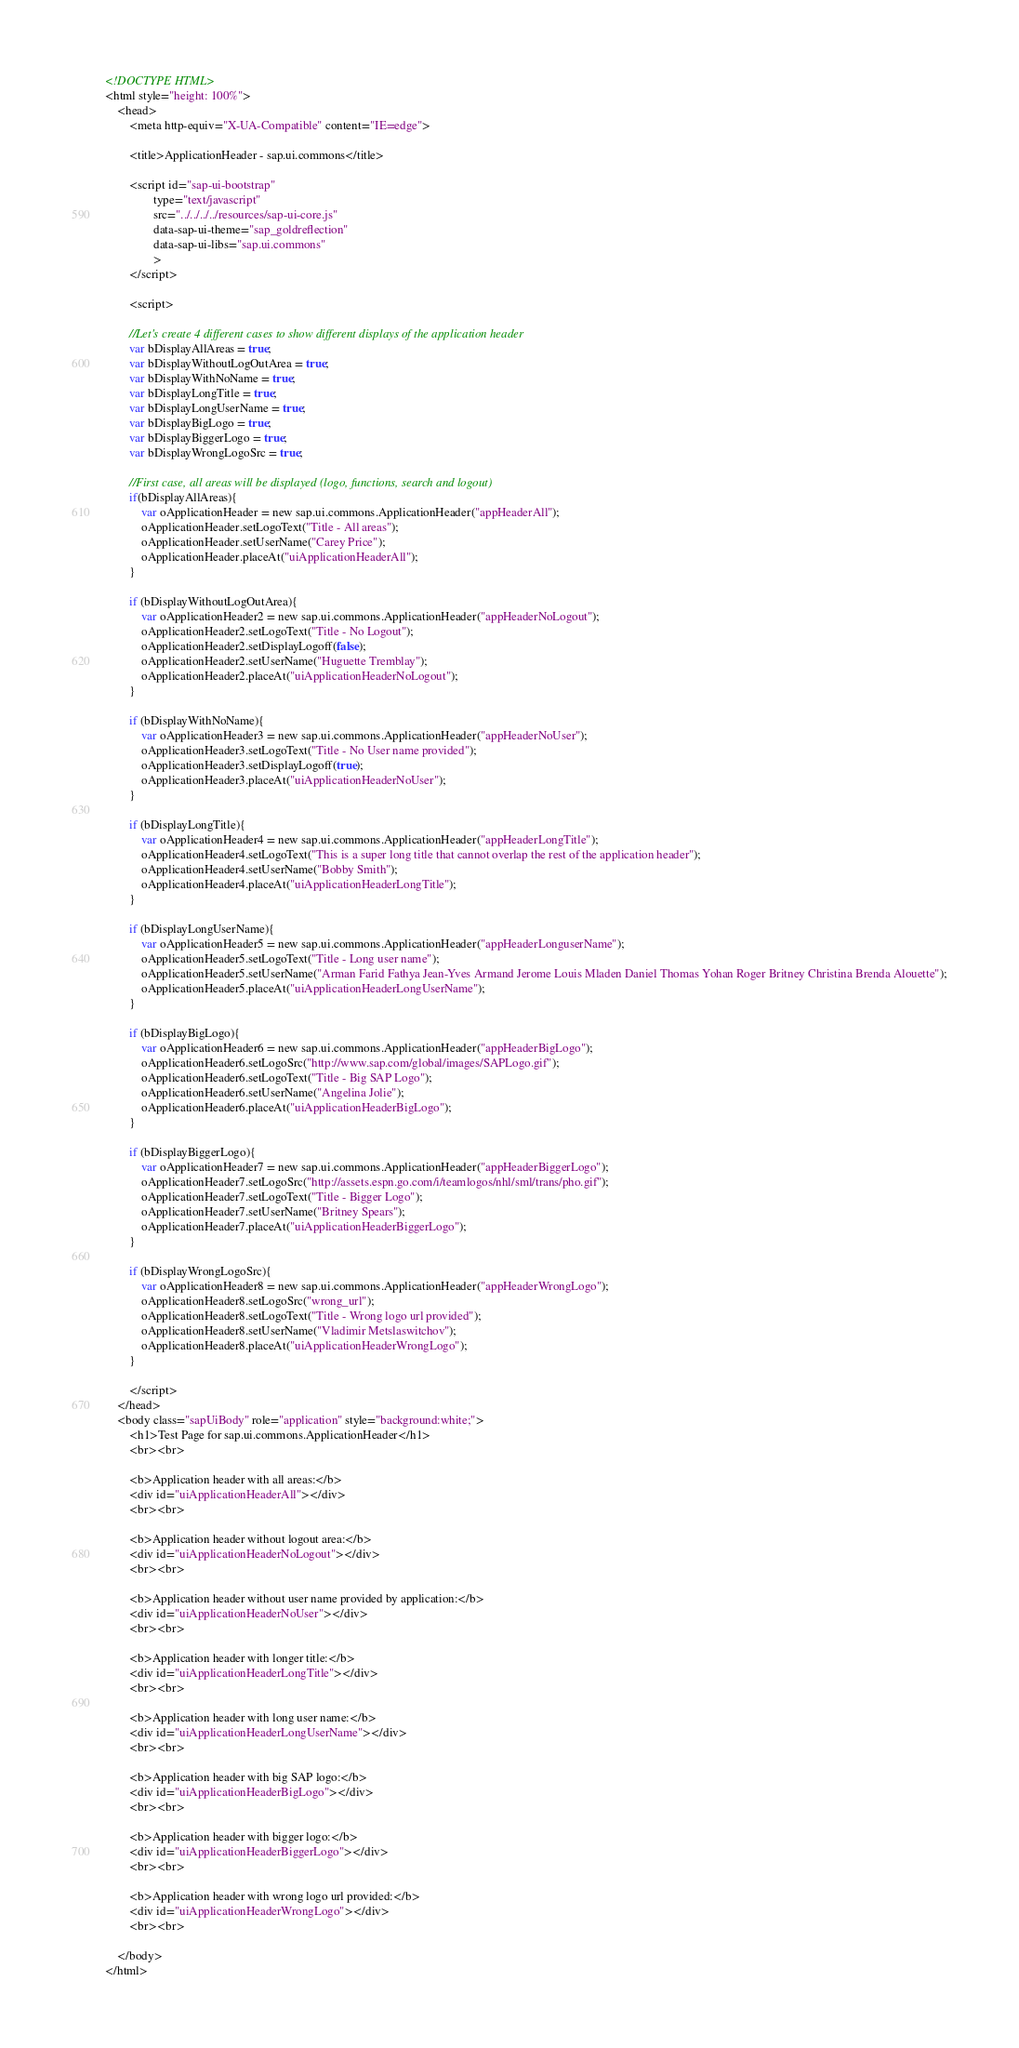<code> <loc_0><loc_0><loc_500><loc_500><_HTML_><!DOCTYPE HTML>
<html style="height: 100%">
	<head>
		<meta http-equiv="X-UA-Compatible" content="IE=edge">

		<title>ApplicationHeader - sap.ui.commons</title>

		<script id="sap-ui-bootstrap"
				type="text/javascript"
				src="../../../../resources/sap-ui-core.js"
				data-sap-ui-theme="sap_goldreflection"
				data-sap-ui-libs="sap.ui.commons"
				>
		</script>

		<script>

		//Let's create 4 different cases to show different displays of the application header
		var bDisplayAllAreas = true;
		var bDisplayWithoutLogOutArea = true;
		var bDisplayWithNoName = true;
		var bDisplayLongTitle = true;
		var bDisplayLongUserName = true;
		var bDisplayBigLogo = true;
		var bDisplayBiggerLogo = true;
		var bDisplayWrongLogoSrc = true;

		//First case, all areas will be displayed (logo, functions, search and logout)
		if(bDisplayAllAreas){
			var oApplicationHeader = new sap.ui.commons.ApplicationHeader("appHeaderAll");
			oApplicationHeader.setLogoText("Title - All areas");
			oApplicationHeader.setUserName("Carey Price");
			oApplicationHeader.placeAt("uiApplicationHeaderAll");
		}

		if (bDisplayWithoutLogOutArea){
			var oApplicationHeader2 = new sap.ui.commons.ApplicationHeader("appHeaderNoLogout");
			oApplicationHeader2.setLogoText("Title - No Logout");
			oApplicationHeader2.setDisplayLogoff(false);
			oApplicationHeader2.setUserName("Huguette Tremblay");
			oApplicationHeader2.placeAt("uiApplicationHeaderNoLogout");
		}

		if (bDisplayWithNoName){
			var oApplicationHeader3 = new sap.ui.commons.ApplicationHeader("appHeaderNoUser");
			oApplicationHeader3.setLogoText("Title - No User name provided");
			oApplicationHeader3.setDisplayLogoff(true);
			oApplicationHeader3.placeAt("uiApplicationHeaderNoUser");
		}

		if (bDisplayLongTitle){
			var oApplicationHeader4 = new sap.ui.commons.ApplicationHeader("appHeaderLongTitle");
			oApplicationHeader4.setLogoText("This is a super long title that cannot overlap the rest of the application header");
			oApplicationHeader4.setUserName("Bobby Smith");
			oApplicationHeader4.placeAt("uiApplicationHeaderLongTitle");
		}

		if (bDisplayLongUserName){
			var oApplicationHeader5 = new sap.ui.commons.ApplicationHeader("appHeaderLonguserName");
			oApplicationHeader5.setLogoText("Title - Long user name");
			oApplicationHeader5.setUserName("Arman Farid Fathya Jean-Yves Armand Jerome Louis Mladen Daniel Thomas Yohan Roger Britney Christina Brenda Alouette");
			oApplicationHeader5.placeAt("uiApplicationHeaderLongUserName");
		}

		if (bDisplayBigLogo){
			var oApplicationHeader6 = new sap.ui.commons.ApplicationHeader("appHeaderBigLogo");
			oApplicationHeader6.setLogoSrc("http://www.sap.com/global/images/SAPLogo.gif");
			oApplicationHeader6.setLogoText("Title - Big SAP Logo");
			oApplicationHeader6.setUserName("Angelina Jolie");
			oApplicationHeader6.placeAt("uiApplicationHeaderBigLogo");
		}

		if (bDisplayBiggerLogo){
			var oApplicationHeader7 = new sap.ui.commons.ApplicationHeader("appHeaderBiggerLogo");
			oApplicationHeader7.setLogoSrc("http://assets.espn.go.com/i/teamlogos/nhl/sml/trans/pho.gif");
			oApplicationHeader7.setLogoText("Title - Bigger Logo");
			oApplicationHeader7.setUserName("Britney Spears");
			oApplicationHeader7.placeAt("uiApplicationHeaderBiggerLogo");
		}

		if (bDisplayWrongLogoSrc){
			var oApplicationHeader8 = new sap.ui.commons.ApplicationHeader("appHeaderWrongLogo");
			oApplicationHeader8.setLogoSrc("wrong_url");
			oApplicationHeader8.setLogoText("Title - Wrong logo url provided");
			oApplicationHeader8.setUserName("Vladimir Metslaswitchov");
			oApplicationHeader8.placeAt("uiApplicationHeaderWrongLogo");
		}

		</script>
	</head>
	<body class="sapUiBody" role="application" style="background:white;">
		<h1>Test Page for sap.ui.commons.ApplicationHeader</h1>
		<br><br>

		<b>Application header with all areas:</b>
		<div id="uiApplicationHeaderAll"></div>
		<br><br>

		<b>Application header without logout area:</b>
		<div id="uiApplicationHeaderNoLogout"></div>
		<br><br>

		<b>Application header without user name provided by application:</b>
		<div id="uiApplicationHeaderNoUser"></div>
		<br><br>

		<b>Application header with longer title:</b>
		<div id="uiApplicationHeaderLongTitle"></div>
		<br><br>

		<b>Application header with long user name:</b>
		<div id="uiApplicationHeaderLongUserName"></div>
		<br><br>

		<b>Application header with big SAP logo:</b>
		<div id="uiApplicationHeaderBigLogo"></div>
		<br><br>

		<b>Application header with bigger logo:</b>
		<div id="uiApplicationHeaderBiggerLogo"></div>
		<br><br>

		<b>Application header with wrong logo url provided:</b>
		<div id="uiApplicationHeaderWrongLogo"></div>
		<br><br>

	</body>
</html>
</code> 